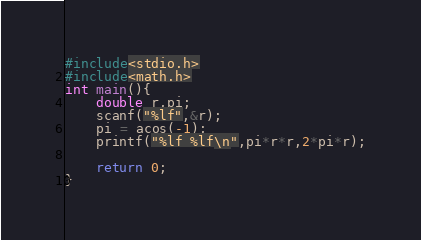<code> <loc_0><loc_0><loc_500><loc_500><_C_>#include<stdio.h>
#include<math.h>
int main(){
    double r,pi;
    scanf("%lf",&r);
    pi = acos(-1);
    printf("%lf %lf\n",pi*r*r,2*pi*r);
    
    return 0;
}

</code> 